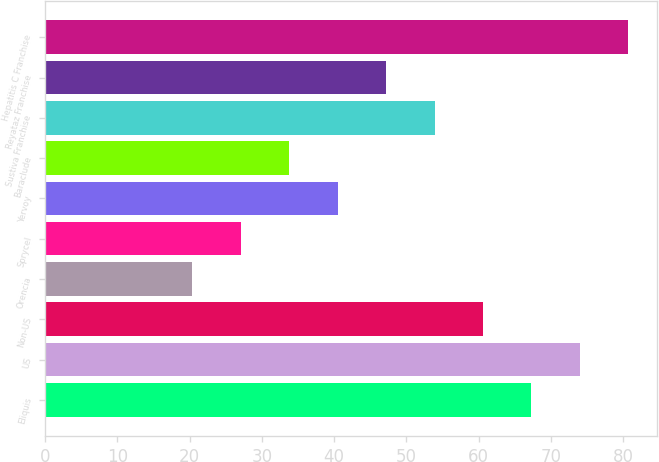<chart> <loc_0><loc_0><loc_500><loc_500><bar_chart><fcel>Eliquis<fcel>US<fcel>Non-US<fcel>Orencia<fcel>Sprycel<fcel>Yervoy<fcel>Baraclude<fcel>Sustiva Franchise<fcel>Reyataz Franchise<fcel>Hepatitis C Franchise<nl><fcel>67.3<fcel>74<fcel>60.6<fcel>20.4<fcel>27.1<fcel>40.5<fcel>33.8<fcel>53.9<fcel>47.2<fcel>80.7<nl></chart> 